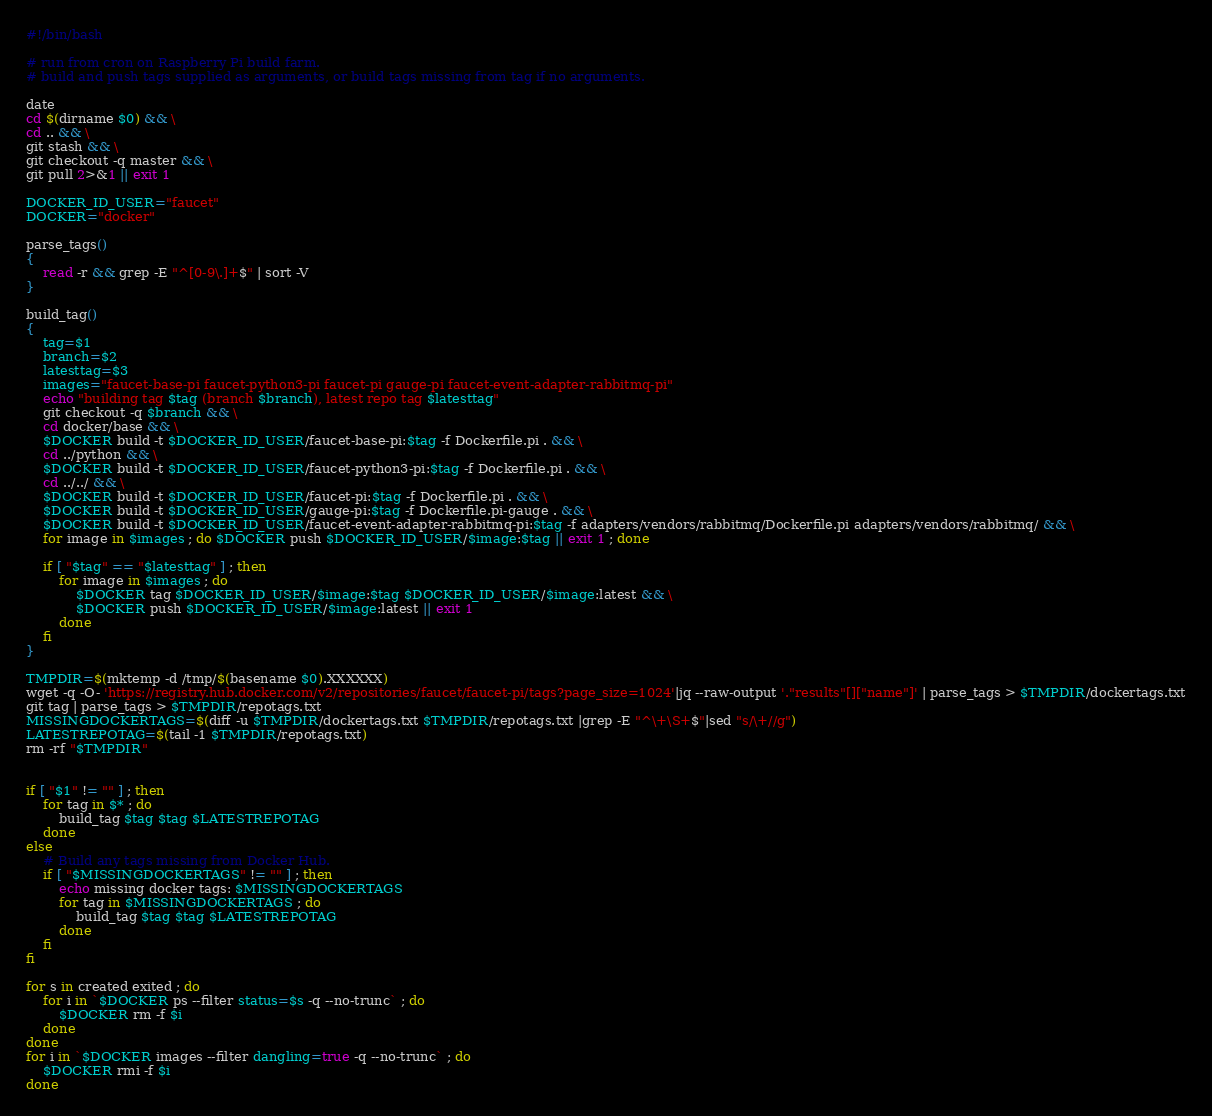Convert code to text. <code><loc_0><loc_0><loc_500><loc_500><_Bash_>#!/bin/bash

# run from cron on Raspberry Pi build farm.
# build and push tags supplied as arguments, or build tags missing from tag if no arguments.

date
cd $(dirname $0) && \
cd .. && \
git stash && \
git checkout -q master && \
git pull 2>&1 || exit 1

DOCKER_ID_USER="faucet"
DOCKER="docker"

parse_tags()
{
    read -r && grep -E "^[0-9\.]+$" | sort -V
}

build_tag()
{
    tag=$1
    branch=$2
    latesttag=$3
    images="faucet-base-pi faucet-python3-pi faucet-pi gauge-pi faucet-event-adapter-rabbitmq-pi"
    echo "building tag $tag (branch $branch), latest repo tag $latesttag"
    git checkout -q $branch && \
    cd docker/base && \
    $DOCKER build -t $DOCKER_ID_USER/faucet-base-pi:$tag -f Dockerfile.pi . && \
    cd ../python && \
    $DOCKER build -t $DOCKER_ID_USER/faucet-python3-pi:$tag -f Dockerfile.pi . && \
    cd ../../ && \
    $DOCKER build -t $DOCKER_ID_USER/faucet-pi:$tag -f Dockerfile.pi . && \
    $DOCKER build -t $DOCKER_ID_USER/gauge-pi:$tag -f Dockerfile.pi-gauge . && \
    $DOCKER build -t $DOCKER_ID_USER/faucet-event-adapter-rabbitmq-pi:$tag -f adapters/vendors/rabbitmq/Dockerfile.pi adapters/vendors/rabbitmq/ && \
    for image in $images ; do $DOCKER push $DOCKER_ID_USER/$image:$tag || exit 1 ; done

    if [ "$tag" == "$latesttag" ] ; then
        for image in $images ; do
            $DOCKER tag $DOCKER_ID_USER/$image:$tag $DOCKER_ID_USER/$image:latest && \
            $DOCKER push $DOCKER_ID_USER/$image:latest || exit 1
        done
    fi
}

TMPDIR=$(mktemp -d /tmp/$(basename $0).XXXXXX)
wget -q -O- 'https://registry.hub.docker.com/v2/repositories/faucet/faucet-pi/tags?page_size=1024'|jq --raw-output '."results"[]["name"]' | parse_tags > $TMPDIR/dockertags.txt
git tag | parse_tags > $TMPDIR/repotags.txt
MISSINGDOCKERTAGS=$(diff -u $TMPDIR/dockertags.txt $TMPDIR/repotags.txt |grep -E "^\+\S+$"|sed "s/\+//g")
LATESTREPOTAG=$(tail -1 $TMPDIR/repotags.txt)
rm -rf "$TMPDIR"


if [ "$1" != "" ] ; then
    for tag in $* ; do
        build_tag $tag $tag $LATESTREPOTAG
    done
else
    # Build any tags missing from Docker Hub.
    if [ "$MISSINGDOCKERTAGS" != "" ] ; then
        echo missing docker tags: $MISSINGDOCKERTAGS
        for tag in $MISSINGDOCKERTAGS ; do
            build_tag $tag $tag $LATESTREPOTAG
        done
    fi
fi

for s in created exited ; do
    for i in `$DOCKER ps --filter status=$s -q --no-trunc` ; do
        $DOCKER rm -f $i
    done
done
for i in `$DOCKER images --filter dangling=true -q --no-trunc` ; do
    $DOCKER rmi -f $i
done
</code> 